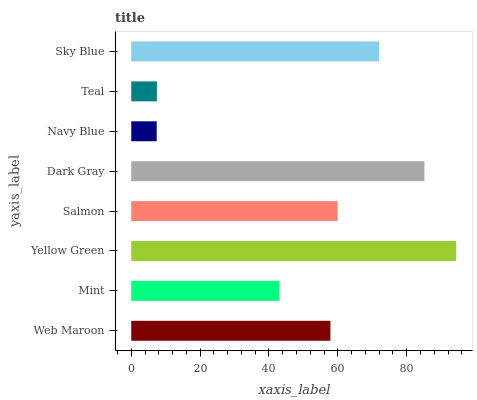Is Navy Blue the minimum?
Answer yes or no. Yes. Is Yellow Green the maximum?
Answer yes or no. Yes. Is Mint the minimum?
Answer yes or no. No. Is Mint the maximum?
Answer yes or no. No. Is Web Maroon greater than Mint?
Answer yes or no. Yes. Is Mint less than Web Maroon?
Answer yes or no. Yes. Is Mint greater than Web Maroon?
Answer yes or no. No. Is Web Maroon less than Mint?
Answer yes or no. No. Is Salmon the high median?
Answer yes or no. Yes. Is Web Maroon the low median?
Answer yes or no. Yes. Is Web Maroon the high median?
Answer yes or no. No. Is Mint the low median?
Answer yes or no. No. 